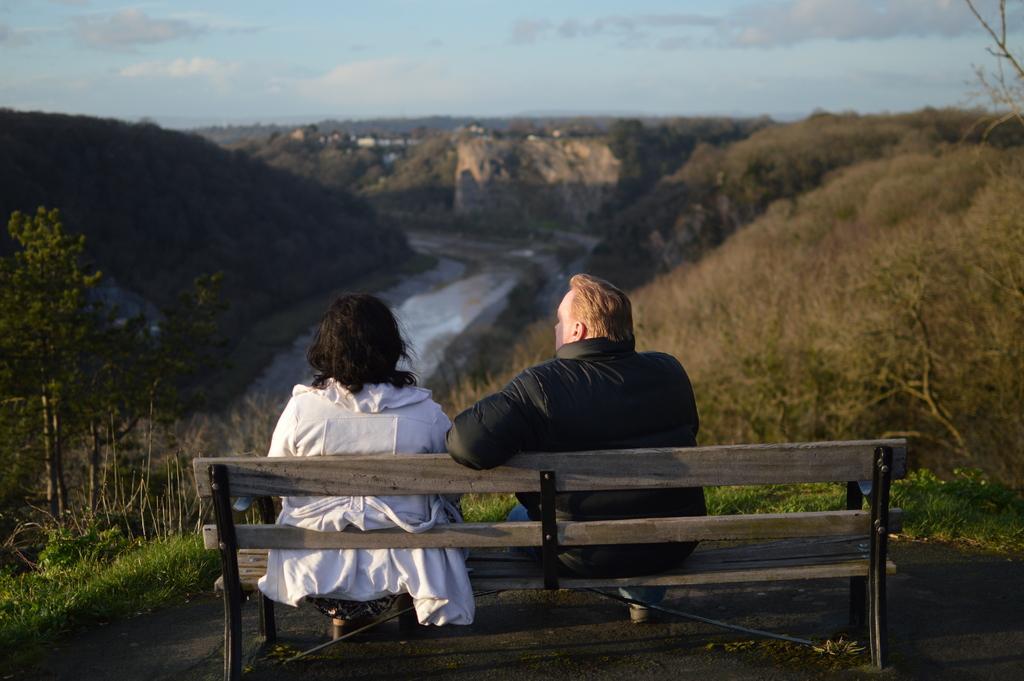How would you summarize this image in a sentence or two? There is a couple sitting on this wooden chair. This is a sky with clouds. This is a landscape. 